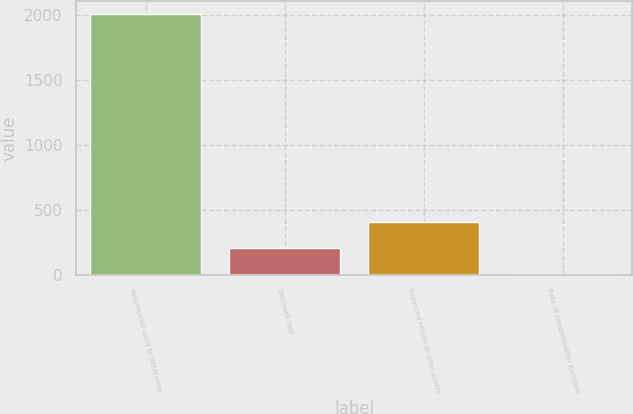Convert chart. <chart><loc_0><loc_0><loc_500><loc_500><bar_chart><fcel>assumption used to determine<fcel>Discount rate<fcel>Expected return on plan assets<fcel>Rate of compensation increase<nl><fcel>2008<fcel>204.4<fcel>404.8<fcel>4<nl></chart> 